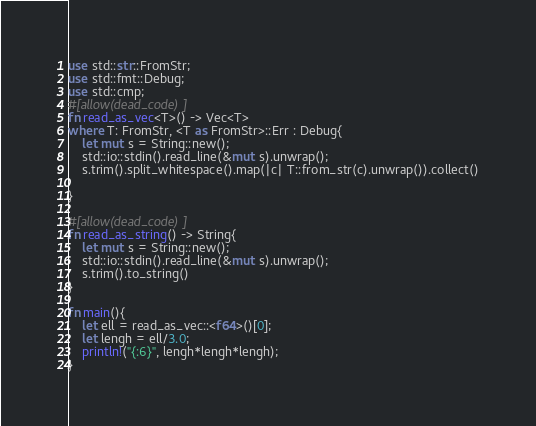<code> <loc_0><loc_0><loc_500><loc_500><_Rust_>use std::str::FromStr;
use std::fmt::Debug;
use std::cmp;
#[allow(dead_code)]
fn read_as_vec<T>() -> Vec<T>
where T: FromStr, <T as FromStr>::Err : Debug{
    let mut s = String::new();
    std::io::stdin().read_line(&mut s).unwrap();
    s.trim().split_whitespace().map(|c| T::from_str(c).unwrap()).collect()

}

#[allow(dead_code)]
fn read_as_string() -> String{
    let mut s = String::new();
    std::io::stdin().read_line(&mut s).unwrap();
    s.trim().to_string()
}

fn main(){
    let ell = read_as_vec::<f64>()[0];
    let lengh = ell/3.0;
    println!("{:6}", lengh*lengh*lengh);
}
</code> 